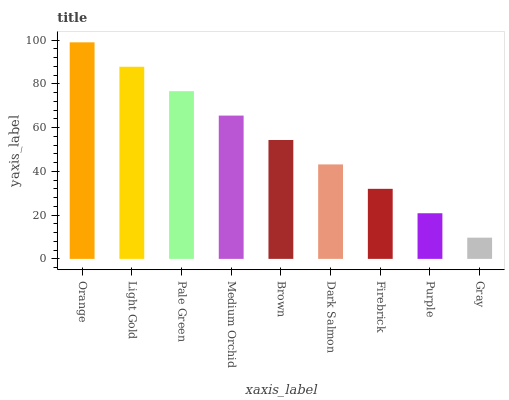Is Gray the minimum?
Answer yes or no. Yes. Is Orange the maximum?
Answer yes or no. Yes. Is Light Gold the minimum?
Answer yes or no. No. Is Light Gold the maximum?
Answer yes or no. No. Is Orange greater than Light Gold?
Answer yes or no. Yes. Is Light Gold less than Orange?
Answer yes or no. Yes. Is Light Gold greater than Orange?
Answer yes or no. No. Is Orange less than Light Gold?
Answer yes or no. No. Is Brown the high median?
Answer yes or no. Yes. Is Brown the low median?
Answer yes or no. Yes. Is Orange the high median?
Answer yes or no. No. Is Gray the low median?
Answer yes or no. No. 